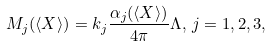<formula> <loc_0><loc_0><loc_500><loc_500>M _ { j } ( \langle X \rangle ) = k _ { j } \frac { \alpha _ { j } ( \langle X \rangle ) } { 4 \pi } \Lambda , \, j = 1 , 2 , 3 ,</formula> 